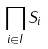<formula> <loc_0><loc_0><loc_500><loc_500>\prod _ { i \in I } S _ { i }</formula> 